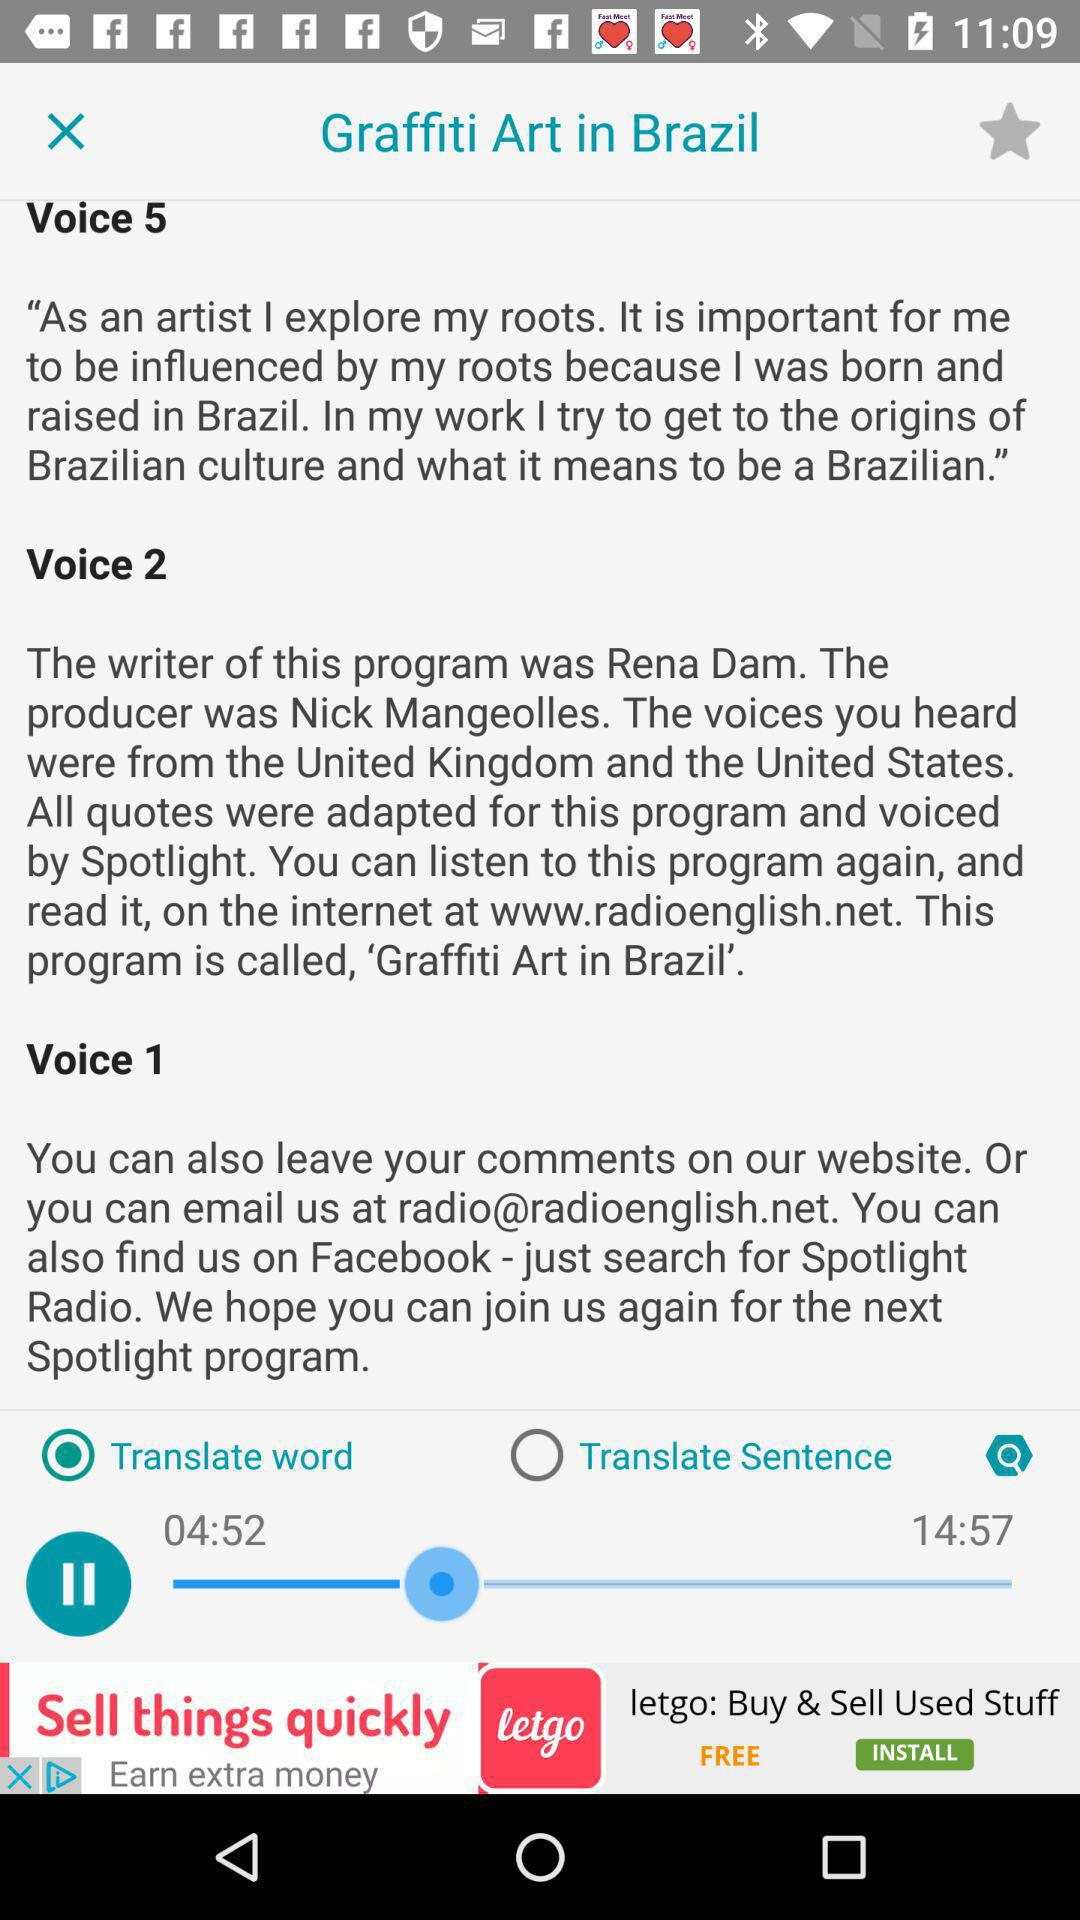What is the status of "Translate Sentence"? The status is "off". 